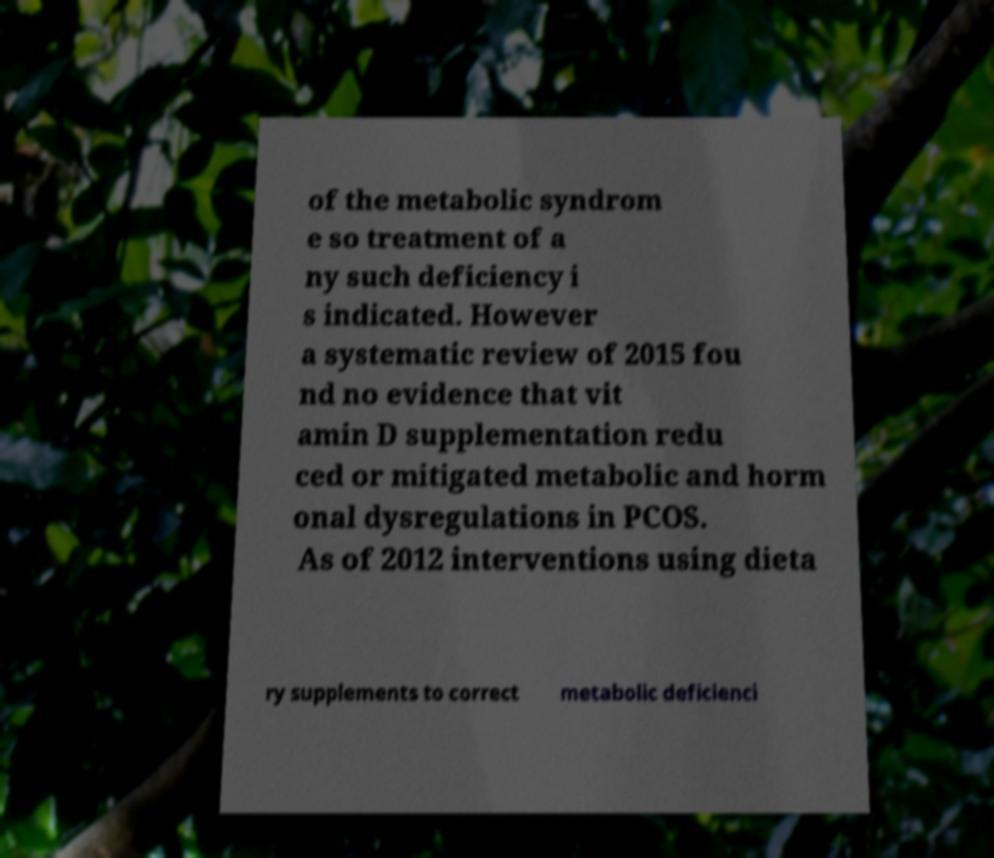There's text embedded in this image that I need extracted. Can you transcribe it verbatim? of the metabolic syndrom e so treatment of a ny such deficiency i s indicated. However a systematic review of 2015 fou nd no evidence that vit amin D supplementation redu ced or mitigated metabolic and horm onal dysregulations in PCOS. As of 2012 interventions using dieta ry supplements to correct metabolic deficienci 